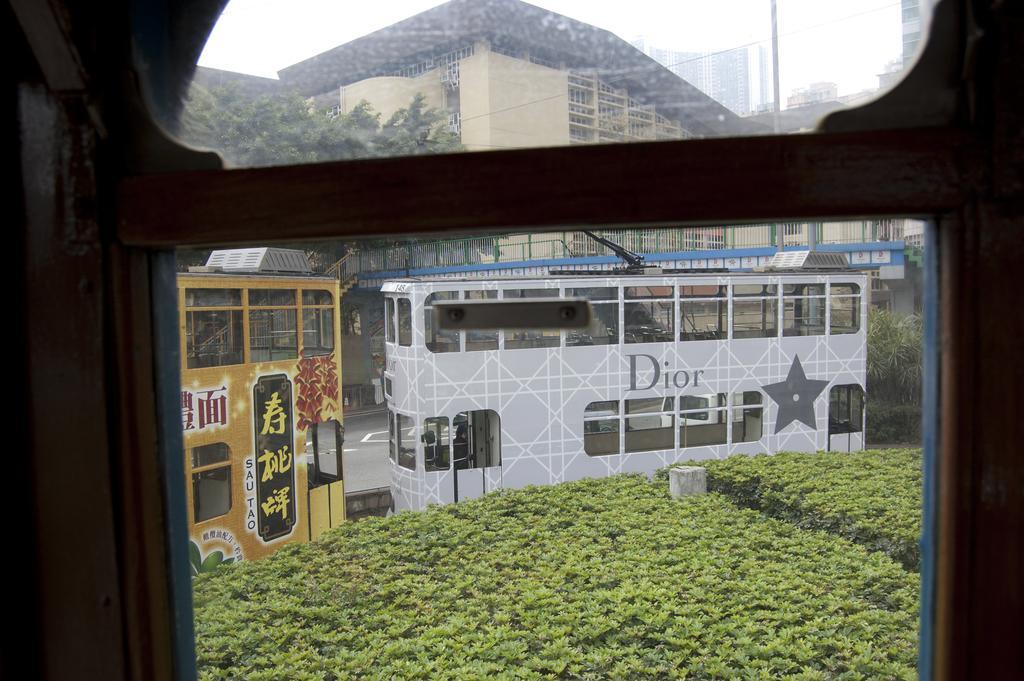Can you describe this image briefly? In this image we can see buildings, locomotives, railings, electric poles, electric cables, bushes, trees and sky. 